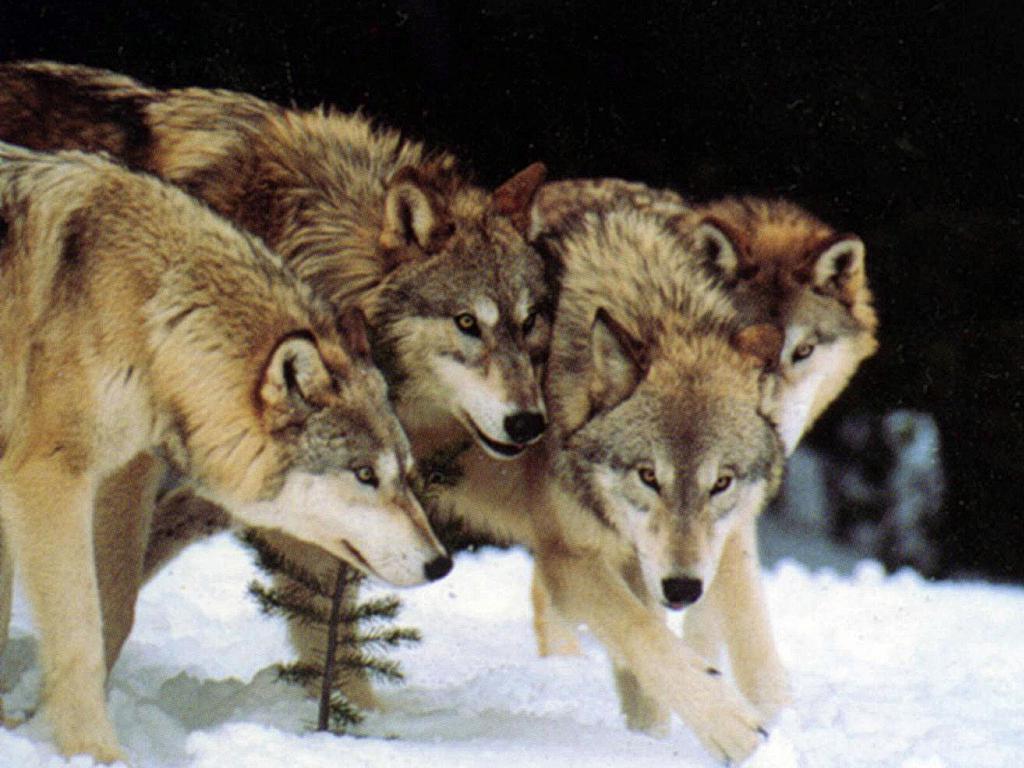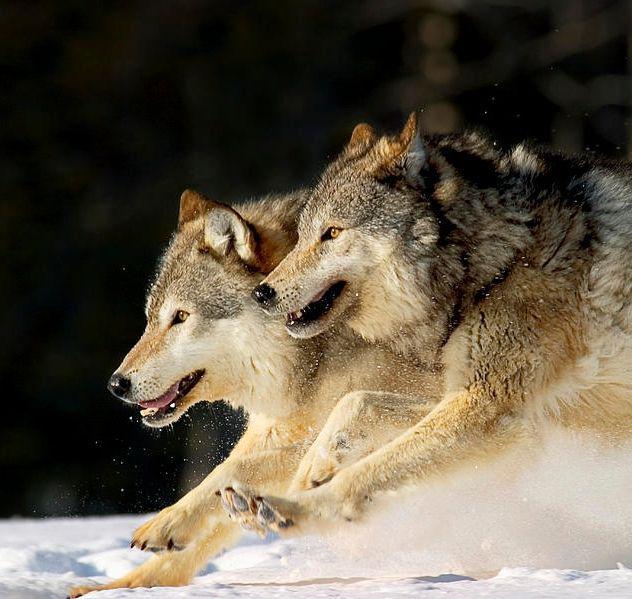The first image is the image on the left, the second image is the image on the right. Assess this claim about the two images: "All images show wolves on snow, and the right image contains more wolves than the left image.". Correct or not? Answer yes or no. No. The first image is the image on the left, the second image is the image on the right. For the images shown, is this caption "There are seven wolves in total." true? Answer yes or no. No. 